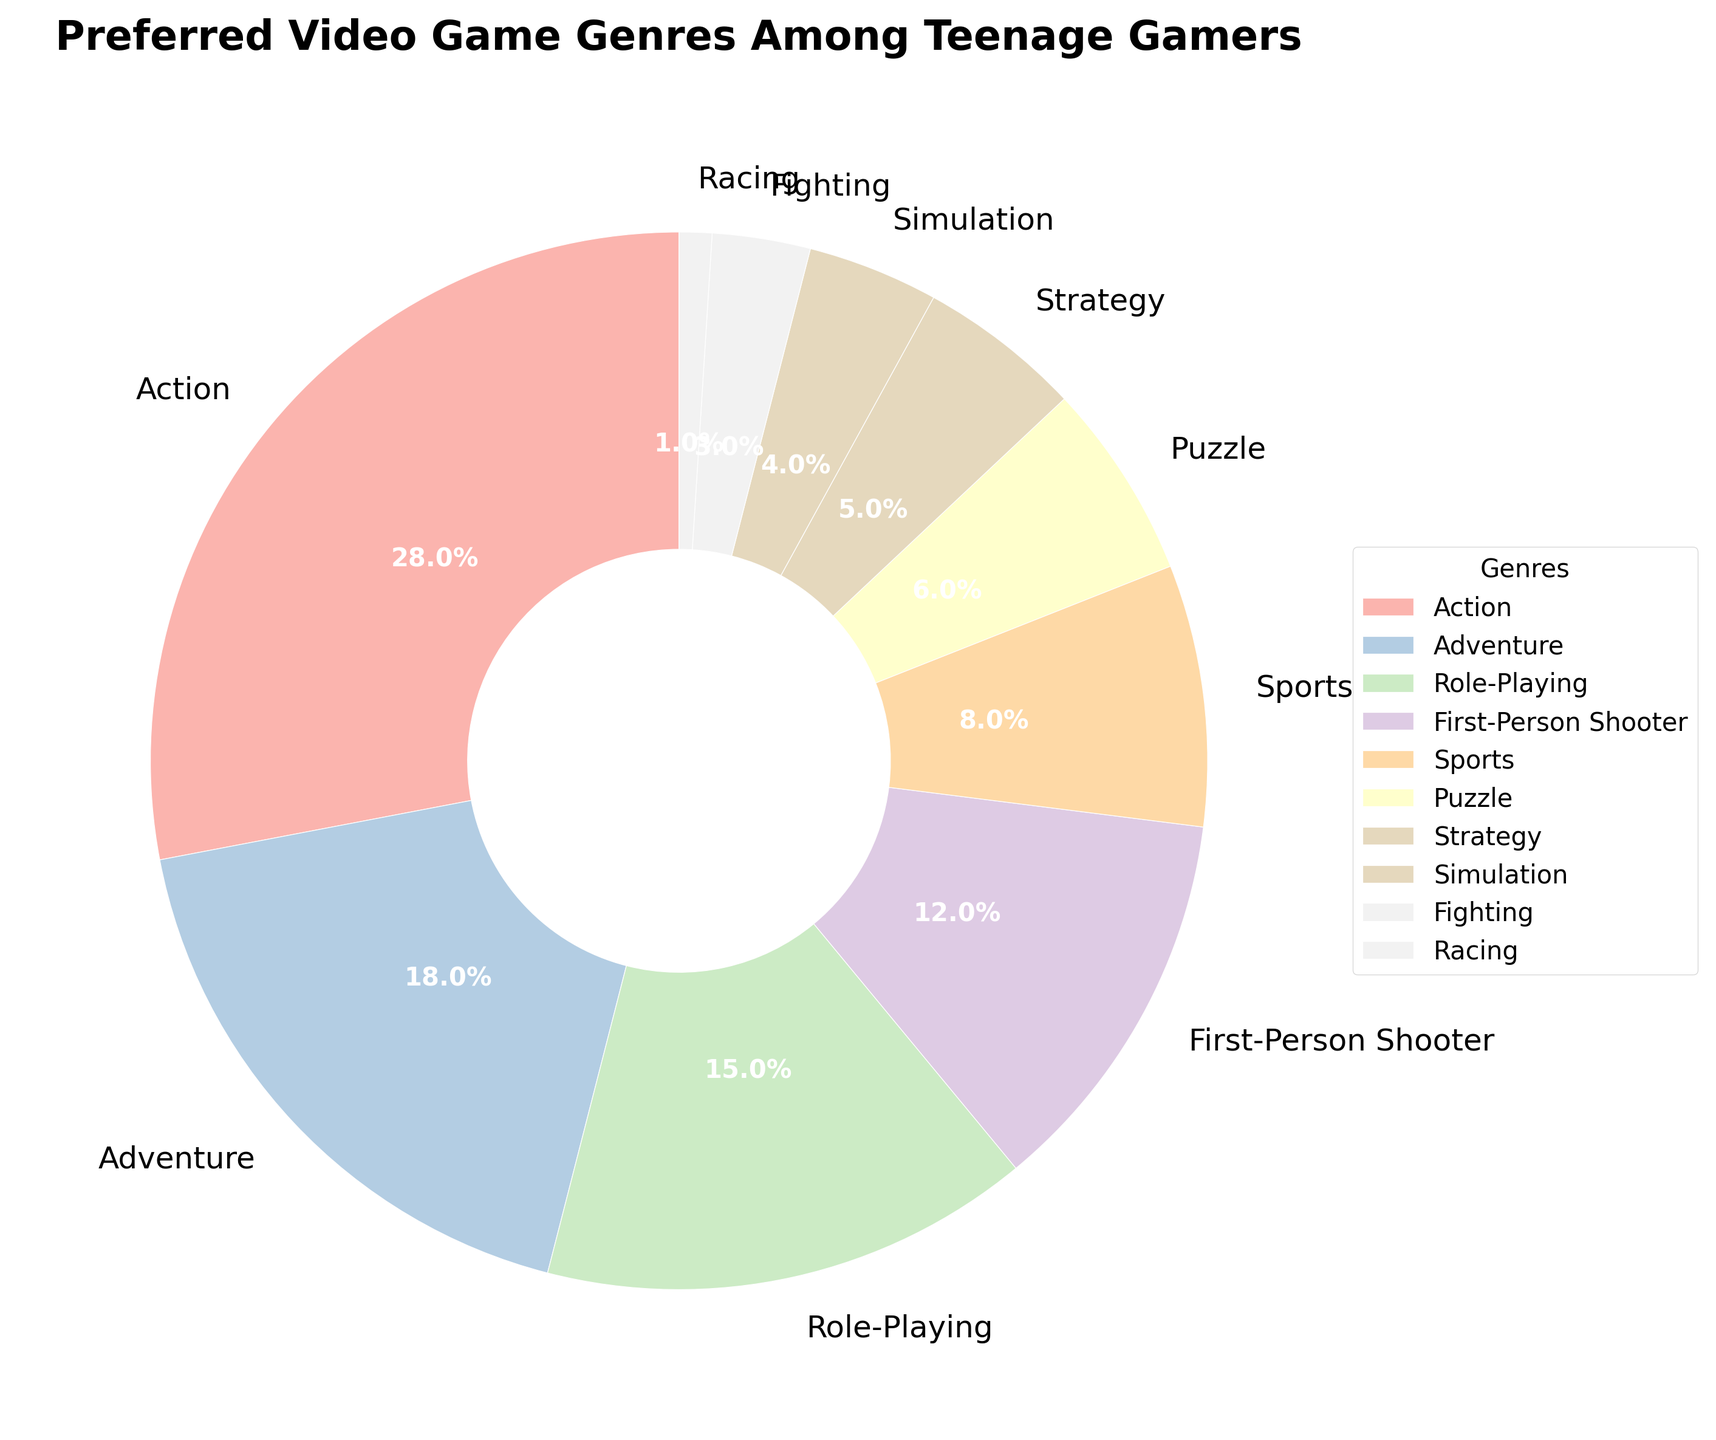Which video game genre is the most preferred among teenage gamers? The pie chart shows that the genre with the largest slice is marked as 'Action' with 28%. This indicates it is the most preferred genre.
Answer: Action Which genre has the smallest share among teenage gamers according to the pie chart? By examining the chart, the smallest slice is labeled 'Racing' which makes up only 1% of the chart, indicating it has the smallest share.
Answer: Racing How does the percentage of teenagers who prefer Adventure games compare to those who prefer Role-Playing games? The pie chart shows that Adventure games have an 18% preference rate while Role-Playing games have a 15% preference rate. Comparing these, Adventure games have a higher preference percentage than Role-Playing games.
Answer: Adventure is higher What is the combined percentage of teenagers who prefer Action, Adventure, and Role-Playing games? Add the percentages for Action, Adventure, and Role-Playing: 28% (Action) + 18% (Adventure) + 15% (Role-Playing) = 61%.
Answer: 61% Compare the popularity between First-Person Shooter and Sports games. Which is more preferred and by how much? The pie chart shows First-Person Shooter at 12% and Sports games at 8%. To find out which is more preferred and by how much, subtract the smaller percentage from the larger percentage: 12% - 8% = 4%. Thus, First-Person Shooter is more preferred by 4%.
Answer: First-Person Shooter by 4% What is the sum of percentages for genres that each have less than 5% preference? According to the chart, genres with less than 5% preference are Strategy (5%), Simulation (4%), Fighting (3%), and Racing (1%). Adding these together: 5% + 4% + 3% + 1% = 13%.
Answer: 13% Of the genres listed, which two have the same color and how can you identify them visually? From the visual perspective, it is unlikely that any genres have the exact same color since different shades or tones are used. However, genres with colors that appear visually similar may need close inspection. Each segment's color and labeling clarify this, with no two genres appearing to overlap in color.
Answer: No two genres have the same color Which genre's preference percentage is closest to half of Action's preference percentage? Action has a 28% preference. Half of 28% is 14%. Role-Playing has a 15% preference, which is closest to 14%. Verifying, the distance from 14% to 15% is 1% while to other genres (e.g., Strategy at 5% being 9% away) is greater.
Answer: Role-Playing 